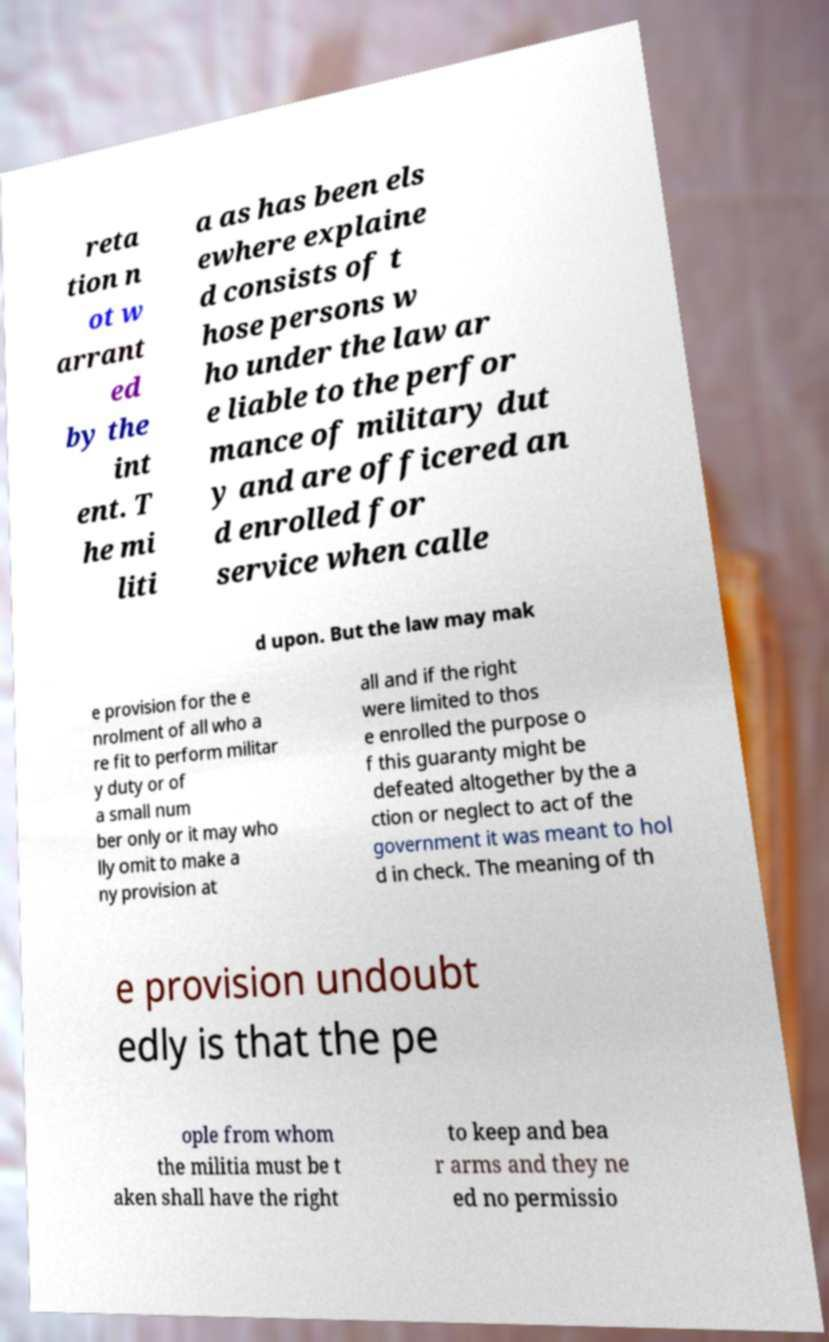There's text embedded in this image that I need extracted. Can you transcribe it verbatim? reta tion n ot w arrant ed by the int ent. T he mi liti a as has been els ewhere explaine d consists of t hose persons w ho under the law ar e liable to the perfor mance of military dut y and are officered an d enrolled for service when calle d upon. But the law may mak e provision for the e nrolment of all who a re fit to perform militar y duty or of a small num ber only or it may who lly omit to make a ny provision at all and if the right were limited to thos e enrolled the purpose o f this guaranty might be defeated altogether by the a ction or neglect to act of the government it was meant to hol d in check. The meaning of th e provision undoubt edly is that the pe ople from whom the militia must be t aken shall have the right to keep and bea r arms and they ne ed no permissio 